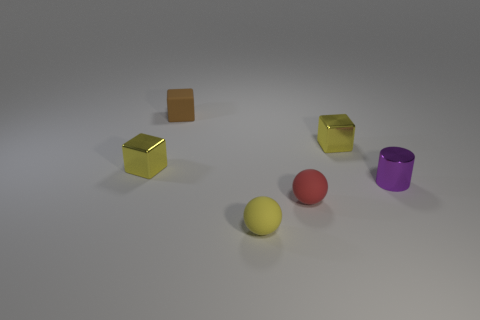The thing that is behind the cylinder and to the right of the yellow sphere has what shape?
Your answer should be compact. Cube. There is another sphere that is the same material as the yellow ball; what color is it?
Your answer should be very brief. Red. Is the number of rubber objects that are on the left side of the red matte object the same as the number of tiny matte balls?
Provide a succinct answer. Yes. There is a brown thing that is the same size as the shiny cylinder; what is its shape?
Keep it short and to the point. Cube. How many other things are there of the same shape as the small brown thing?
Offer a terse response. 2. What number of objects are tiny spheres that are to the right of the tiny brown rubber block or tiny yellow metallic objects?
Provide a succinct answer. 4. What is the shape of the tiny matte object that is behind the cylinder?
Make the answer very short. Cube. Are there the same number of tiny yellow rubber balls on the left side of the brown cube and yellow things behind the tiny purple metal object?
Your response must be concise. No. What color is the metal object that is both behind the cylinder and right of the tiny red matte ball?
Provide a succinct answer. Yellow. The tiny object on the right side of the small yellow block that is to the right of the brown object is made of what material?
Your answer should be very brief. Metal. 